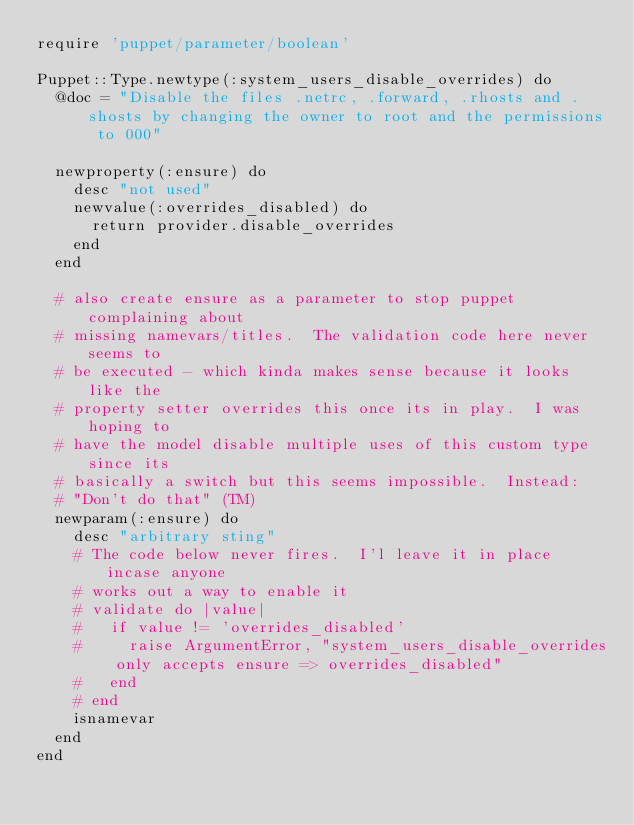Convert code to text. <code><loc_0><loc_0><loc_500><loc_500><_Ruby_>require 'puppet/parameter/boolean'

Puppet::Type.newtype(:system_users_disable_overrides) do
  @doc = "Disable the files .netrc, .forward, .rhosts and .shosts by changing the owner to root and the permissions to 000"

  newproperty(:ensure) do
    desc "not used"
    newvalue(:overrides_disabled) do
      return provider.disable_overrides
    end
  end

  # also create ensure as a parameter to stop puppet complaining about
  # missing namevars/titles.  The validation code here never seems to
  # be executed - which kinda makes sense because it looks like the
  # property setter overrides this once its in play.  I was hoping to
  # have the model disable multiple uses of this custom type since its
  # basically a switch but this seems impossible.  Instead:
  # "Don't do that" (TM)
  newparam(:ensure) do
    desc "arbitrary sting"
    # The code below never fires.  I'l leave it in place incase anyone
    # works out a way to enable it
    # validate do |value|
    #   if value != 'overrides_disabled'
    #     raise ArgumentError, "system_users_disable_overrides only accepts ensure => overrides_disabled"
    #   end
    # end
    isnamevar
  end
end
</code> 